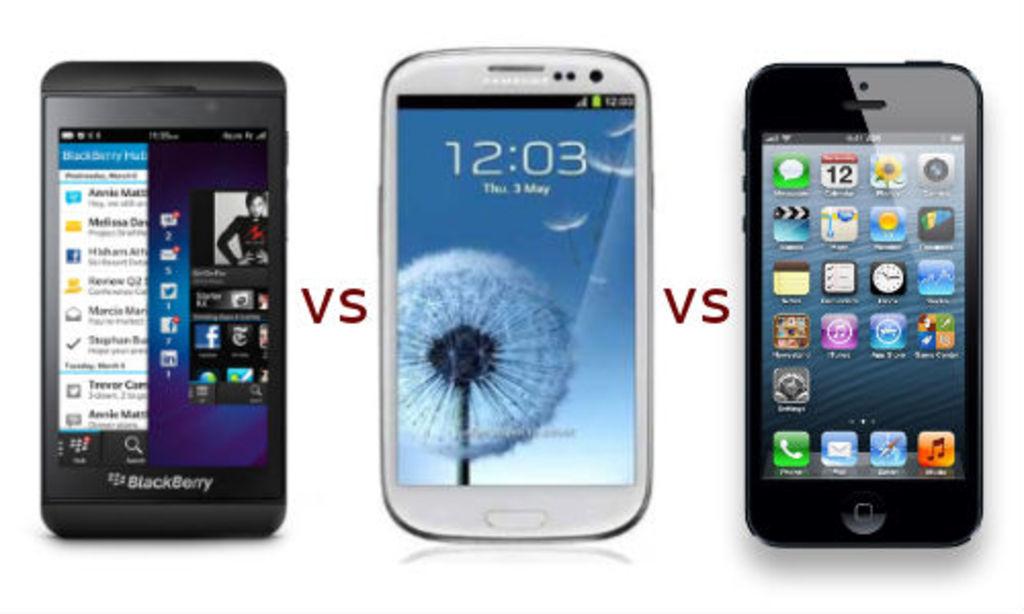How many type of phones do you see?
Your answer should be very brief. Answering does not require reading text in the image. What time is displayed on the center phone?
Make the answer very short. 12:03. 